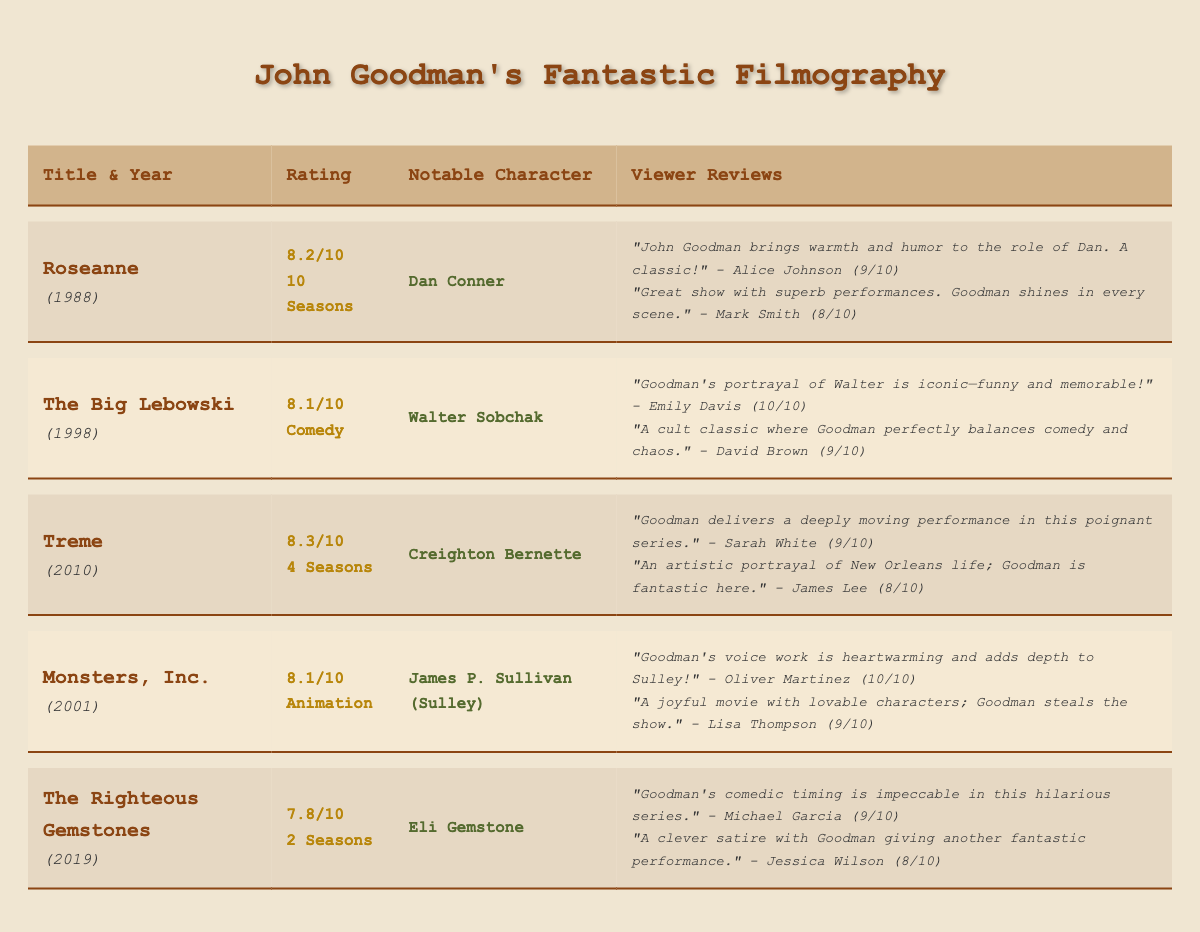What is the highest viewer rating for a show or movie featuring John Goodman? The highest rating listed in the table is 8.3 for "Treme."
Answer: 8.3 Which character did John Goodman portray in "Monsters, Inc."? The notable character he portrayed in "Monsters, Inc." is James P. Sullivan, also known as Sulley.
Answer: James P. Sullivan (Sulley) How many total seasons are there across all shows listed? "Roseanne" has 10 seasons, "Treme" has 4 seasons, and "The Righteous Gemstones" has 2 seasons, totaling 10 + 4 + 2 = 16 seasons.
Answer: 16 seasons What was the average rating of "The Righteous Gemstones"? The average rating for "The Righteous Gemstones" is 7.8.
Answer: 7.8 Did any of the movies or shows receive a perfect rating of 10? Yes, "The Big Lebowski" and "Monsters, Inc." both have viewer reviews that include a perfect rating of 10.
Answer: Yes Who is the reviewer that gave the highest rating to "The Big Lebowski"? The reviewer who gave the highest rating (10/10) to "The Big Lebowski" is Emily Davis.
Answer: Emily Davis What is the difference in average ratings between "Treme" and "The Righteous Gemstones"? "Treme" has an average rating of 8.3 and "The Righteous Gemstones" has an average rating of 7.8. The difference is 8.3 - 7.8 = 0.5.
Answer: 0.5 Which show contains a character that is a comedic figure and how is it rated? "The Righteous Gemstones" features the comedic character Jesse Gemstone and has an average rating of 7.8.
Answer: 7.8 What genre does "The Big Lebowski" belong to, and what is its average rating? "The Big Lebowski" is categorized as a Comedy genre, and its average rating is 8.1.
Answer: Comedy, 8.1 How many viewer reviews were provided for "Monsters, Inc." and what were the ratings? "Monsters, Inc." has two viewer reviews with ratings of 10 and 9.
Answer: 2 reviews, ratings are 10 and 9 